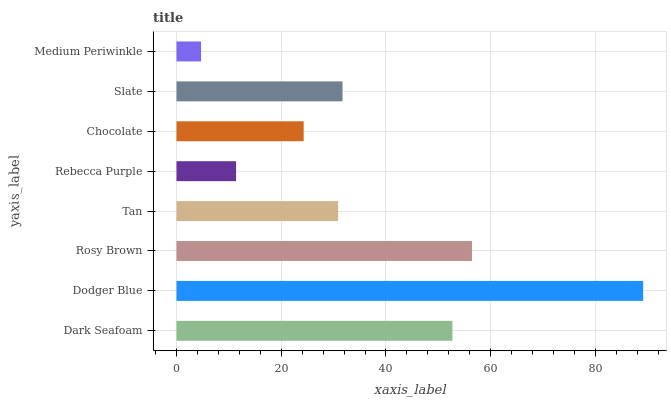Is Medium Periwinkle the minimum?
Answer yes or no. Yes. Is Dodger Blue the maximum?
Answer yes or no. Yes. Is Rosy Brown the minimum?
Answer yes or no. No. Is Rosy Brown the maximum?
Answer yes or no. No. Is Dodger Blue greater than Rosy Brown?
Answer yes or no. Yes. Is Rosy Brown less than Dodger Blue?
Answer yes or no. Yes. Is Rosy Brown greater than Dodger Blue?
Answer yes or no. No. Is Dodger Blue less than Rosy Brown?
Answer yes or no. No. Is Slate the high median?
Answer yes or no. Yes. Is Tan the low median?
Answer yes or no. Yes. Is Dark Seafoam the high median?
Answer yes or no. No. Is Dark Seafoam the low median?
Answer yes or no. No. 